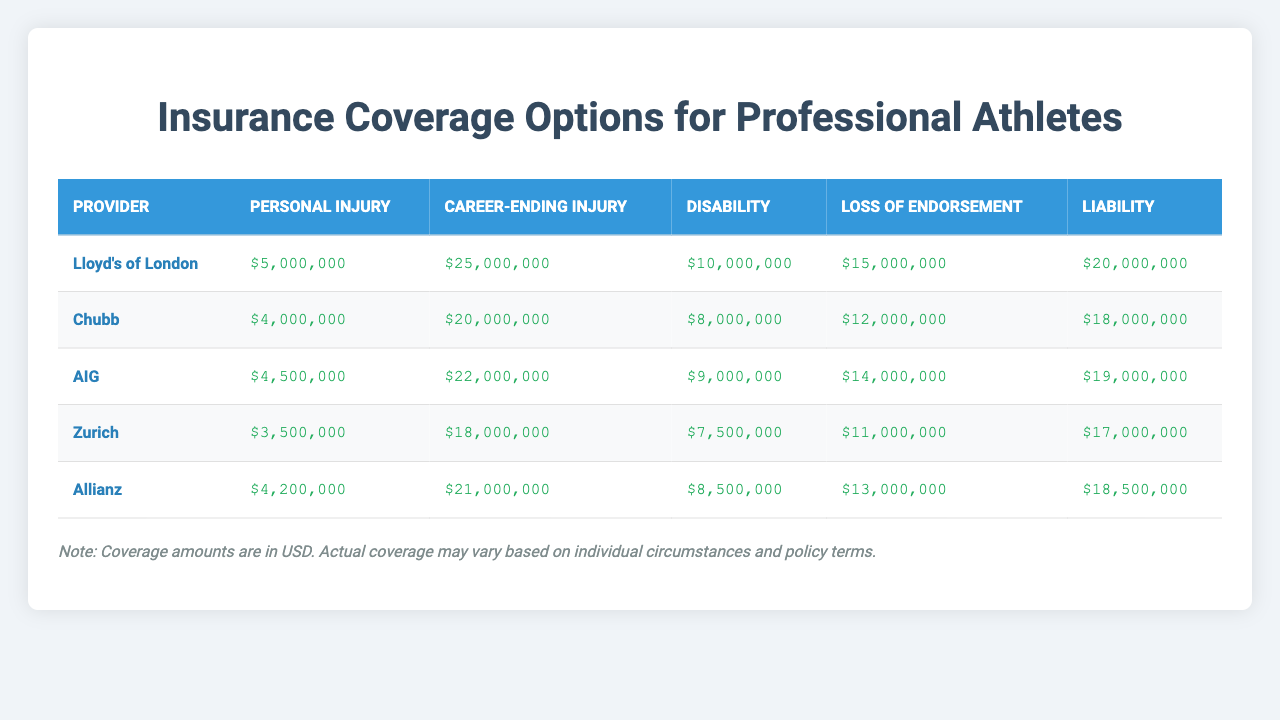What is the maximum coverage amount for Career-Ending Injury? Reviewing the table, the highest amount listed for Career-Ending Injury is provided by Lloyd's of London at $25,000,000.
Answer: $25,000,000 Which provider has the lowest coverage for Personal Injury? According to the table, Zurich offers the lowest coverage for Personal Injury, totaling $3,500,000.
Answer: Zurich What is the total coverage amount for Loss of Endorsement across all providers? Summing the Loss of Endorsement amounts: $15,000,000 (Lloyd's) + $12,000,000 (Chubb) + $14,000,000 (AIG) + $11,000,000 (Zurich) + $13,000,000 (Allianz) equals $65,000,000.
Answer: $65,000,000 Does Allianz provide coverage for Disability that is higher than AIG? Checking the values in the table, Allianz offers $8,500,000 for Disability while AIG offers $9,000,000. Thus, Allianz does not provide higher coverage than AIG.
Answer: No What is the average coverage for Liability among all providers? Calculating the average for Liability: ($20,000,000 + $18,000,000 + $19,000,000 + $17,000,000 + $18,500,000) / 5 equals $18,100,000.
Answer: $18,100,000 Which provider has the highest coverage amount for both Personal Injury and Disability? Analyzing the table, Lloyd's of London has $5,000,000 for Personal Injury and $10,000,000 for Disability, which are the highest amounts compared to other providers for both categories.
Answer: Lloyd's of London Is there any provider that offers exactly $20,000,000 for any type of coverage? Reviewing all coverage amounts, no provider lists $20,000,000 as a coverage option for any type of insurance.
Answer: No What is the difference in coverage for Career-Ending Injury between Lloyd's of London and Chubb? The difference can be calculated as $25,000,000 (Lloyd's) - $20,000,000 (Chubb) = $5,000,000.
Answer: $5,000,000 Which insurance provider has the highest coverage for Loss of Endorsement? Looking at the table, Lloyd's of London has the highest coverage for Loss of Endorsement at $15,000,000.
Answer: Lloyd's of London What is the minimum coverage for Disability among all providers, and which provider offers it? The minimum coverage for Disability is $7,500,000 provided by Zurich, which is the lowest compared to other providers.
Answer: Zurich 